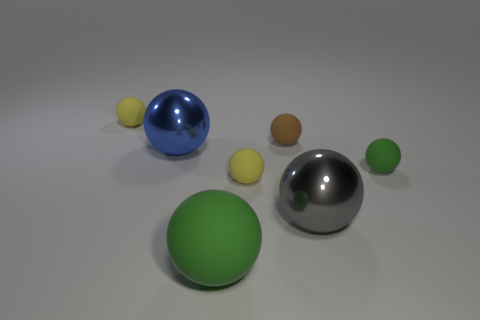Do the blue ball and the small brown ball have the same material?
Make the answer very short. No. What number of cyan blocks are the same material as the small brown sphere?
Provide a succinct answer. 0. How many things are either tiny spheres that are in front of the blue shiny thing or brown matte objects behind the large matte ball?
Your answer should be very brief. 3. Is the number of blue spheres that are on the left side of the big rubber ball greater than the number of yellow balls to the right of the brown matte sphere?
Your answer should be compact. Yes. There is a large metallic sphere to the right of the large green rubber ball; what is its color?
Your response must be concise. Gray. Is there a cyan rubber object of the same shape as the gray object?
Keep it short and to the point. No. How many blue things are metallic balls or big rubber balls?
Provide a succinct answer. 1. Is there a brown sphere of the same size as the brown matte thing?
Keep it short and to the point. No. How many large brown rubber cubes are there?
Offer a very short reply. 0. What number of large objects are either gray rubber spheres or brown things?
Your answer should be very brief. 0. 